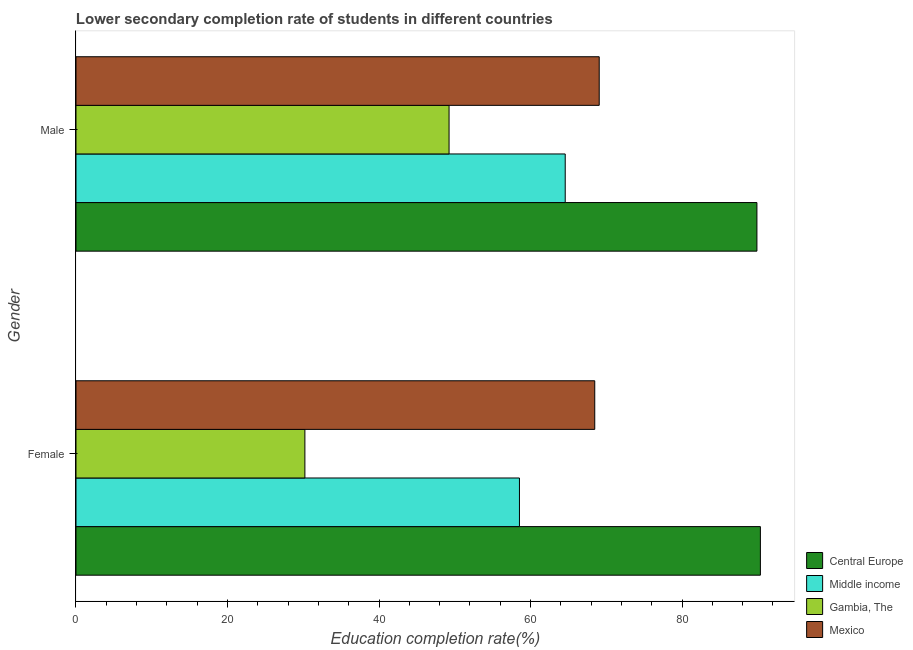How many bars are there on the 1st tick from the top?
Provide a short and direct response. 4. How many bars are there on the 2nd tick from the bottom?
Provide a succinct answer. 4. What is the label of the 2nd group of bars from the top?
Ensure brevity in your answer.  Female. What is the education completion rate of female students in Gambia, The?
Make the answer very short. 30.21. Across all countries, what is the maximum education completion rate of female students?
Provide a short and direct response. 90.34. Across all countries, what is the minimum education completion rate of male students?
Offer a terse response. 49.25. In which country was the education completion rate of male students maximum?
Your answer should be compact. Central Europe. In which country was the education completion rate of female students minimum?
Provide a short and direct response. Gambia, The. What is the total education completion rate of female students in the graph?
Make the answer very short. 247.57. What is the difference between the education completion rate of male students in Middle income and that in Gambia, The?
Keep it short and to the point. 15.33. What is the difference between the education completion rate of female students in Middle income and the education completion rate of male students in Central Europe?
Keep it short and to the point. -31.35. What is the average education completion rate of male students per country?
Offer a terse response. 68.19. What is the difference between the education completion rate of male students and education completion rate of female students in Central Europe?
Make the answer very short. -0.46. What is the ratio of the education completion rate of male students in Gambia, The to that in Central Europe?
Your answer should be very brief. 0.55. In how many countries, is the education completion rate of female students greater than the average education completion rate of female students taken over all countries?
Your response must be concise. 2. What does the 3rd bar from the bottom in Female represents?
Give a very brief answer. Gambia, The. How many bars are there?
Offer a very short reply. 8. Are the values on the major ticks of X-axis written in scientific E-notation?
Make the answer very short. No. Does the graph contain any zero values?
Make the answer very short. No. Does the graph contain grids?
Offer a very short reply. No. How many legend labels are there?
Keep it short and to the point. 4. How are the legend labels stacked?
Your response must be concise. Vertical. What is the title of the graph?
Ensure brevity in your answer.  Lower secondary completion rate of students in different countries. What is the label or title of the X-axis?
Offer a terse response. Education completion rate(%). What is the Education completion rate(%) in Central Europe in Female?
Give a very brief answer. 90.34. What is the Education completion rate(%) of Middle income in Female?
Keep it short and to the point. 58.54. What is the Education completion rate(%) in Gambia, The in Female?
Provide a succinct answer. 30.21. What is the Education completion rate(%) of Mexico in Female?
Give a very brief answer. 68.48. What is the Education completion rate(%) of Central Europe in Male?
Provide a short and direct response. 89.89. What is the Education completion rate(%) in Middle income in Male?
Offer a terse response. 64.58. What is the Education completion rate(%) of Gambia, The in Male?
Your answer should be very brief. 49.25. What is the Education completion rate(%) in Mexico in Male?
Your answer should be very brief. 69.07. Across all Gender, what is the maximum Education completion rate(%) of Central Europe?
Provide a succinct answer. 90.34. Across all Gender, what is the maximum Education completion rate(%) in Middle income?
Ensure brevity in your answer.  64.58. Across all Gender, what is the maximum Education completion rate(%) of Gambia, The?
Your answer should be very brief. 49.25. Across all Gender, what is the maximum Education completion rate(%) in Mexico?
Ensure brevity in your answer.  69.07. Across all Gender, what is the minimum Education completion rate(%) of Central Europe?
Offer a terse response. 89.89. Across all Gender, what is the minimum Education completion rate(%) in Middle income?
Provide a succinct answer. 58.54. Across all Gender, what is the minimum Education completion rate(%) of Gambia, The?
Provide a short and direct response. 30.21. Across all Gender, what is the minimum Education completion rate(%) in Mexico?
Provide a short and direct response. 68.48. What is the total Education completion rate(%) of Central Europe in the graph?
Offer a very short reply. 180.23. What is the total Education completion rate(%) in Middle income in the graph?
Give a very brief answer. 123.12. What is the total Education completion rate(%) in Gambia, The in the graph?
Give a very brief answer. 79.46. What is the total Education completion rate(%) in Mexico in the graph?
Give a very brief answer. 137.55. What is the difference between the Education completion rate(%) of Central Europe in Female and that in Male?
Make the answer very short. 0.46. What is the difference between the Education completion rate(%) in Middle income in Female and that in Male?
Ensure brevity in your answer.  -6.04. What is the difference between the Education completion rate(%) in Gambia, The in Female and that in Male?
Make the answer very short. -19.03. What is the difference between the Education completion rate(%) in Mexico in Female and that in Male?
Make the answer very short. -0.59. What is the difference between the Education completion rate(%) in Central Europe in Female and the Education completion rate(%) in Middle income in Male?
Ensure brevity in your answer.  25.76. What is the difference between the Education completion rate(%) of Central Europe in Female and the Education completion rate(%) of Gambia, The in Male?
Provide a short and direct response. 41.1. What is the difference between the Education completion rate(%) of Central Europe in Female and the Education completion rate(%) of Mexico in Male?
Your answer should be compact. 21.28. What is the difference between the Education completion rate(%) in Middle income in Female and the Education completion rate(%) in Gambia, The in Male?
Your response must be concise. 9.29. What is the difference between the Education completion rate(%) of Middle income in Female and the Education completion rate(%) of Mexico in Male?
Your response must be concise. -10.53. What is the difference between the Education completion rate(%) of Gambia, The in Female and the Education completion rate(%) of Mexico in Male?
Keep it short and to the point. -38.85. What is the average Education completion rate(%) in Central Europe per Gender?
Your answer should be compact. 90.11. What is the average Education completion rate(%) in Middle income per Gender?
Keep it short and to the point. 61.56. What is the average Education completion rate(%) in Gambia, The per Gender?
Offer a terse response. 39.73. What is the average Education completion rate(%) in Mexico per Gender?
Your answer should be very brief. 68.77. What is the difference between the Education completion rate(%) of Central Europe and Education completion rate(%) of Middle income in Female?
Keep it short and to the point. 31.8. What is the difference between the Education completion rate(%) of Central Europe and Education completion rate(%) of Gambia, The in Female?
Provide a short and direct response. 60.13. What is the difference between the Education completion rate(%) in Central Europe and Education completion rate(%) in Mexico in Female?
Provide a succinct answer. 21.87. What is the difference between the Education completion rate(%) in Middle income and Education completion rate(%) in Gambia, The in Female?
Provide a succinct answer. 28.32. What is the difference between the Education completion rate(%) in Middle income and Education completion rate(%) in Mexico in Female?
Offer a very short reply. -9.94. What is the difference between the Education completion rate(%) of Gambia, The and Education completion rate(%) of Mexico in Female?
Ensure brevity in your answer.  -38.26. What is the difference between the Education completion rate(%) of Central Europe and Education completion rate(%) of Middle income in Male?
Keep it short and to the point. 25.31. What is the difference between the Education completion rate(%) in Central Europe and Education completion rate(%) in Gambia, The in Male?
Keep it short and to the point. 40.64. What is the difference between the Education completion rate(%) of Central Europe and Education completion rate(%) of Mexico in Male?
Keep it short and to the point. 20.82. What is the difference between the Education completion rate(%) of Middle income and Education completion rate(%) of Gambia, The in Male?
Give a very brief answer. 15.33. What is the difference between the Education completion rate(%) in Middle income and Education completion rate(%) in Mexico in Male?
Make the answer very short. -4.49. What is the difference between the Education completion rate(%) in Gambia, The and Education completion rate(%) in Mexico in Male?
Offer a terse response. -19.82. What is the ratio of the Education completion rate(%) of Middle income in Female to that in Male?
Keep it short and to the point. 0.91. What is the ratio of the Education completion rate(%) of Gambia, The in Female to that in Male?
Give a very brief answer. 0.61. What is the ratio of the Education completion rate(%) of Mexico in Female to that in Male?
Ensure brevity in your answer.  0.99. What is the difference between the highest and the second highest Education completion rate(%) in Central Europe?
Your answer should be compact. 0.46. What is the difference between the highest and the second highest Education completion rate(%) of Middle income?
Provide a succinct answer. 6.04. What is the difference between the highest and the second highest Education completion rate(%) in Gambia, The?
Your response must be concise. 19.03. What is the difference between the highest and the second highest Education completion rate(%) of Mexico?
Offer a very short reply. 0.59. What is the difference between the highest and the lowest Education completion rate(%) of Central Europe?
Your answer should be compact. 0.46. What is the difference between the highest and the lowest Education completion rate(%) of Middle income?
Your answer should be compact. 6.04. What is the difference between the highest and the lowest Education completion rate(%) of Gambia, The?
Make the answer very short. 19.03. What is the difference between the highest and the lowest Education completion rate(%) of Mexico?
Offer a very short reply. 0.59. 